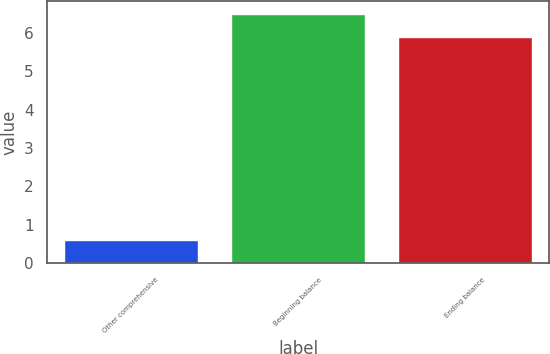Convert chart to OTSL. <chart><loc_0><loc_0><loc_500><loc_500><bar_chart><fcel>Other comprehensive<fcel>Beginning balance<fcel>Ending balance<nl><fcel>0.6<fcel>6.5<fcel>5.9<nl></chart> 